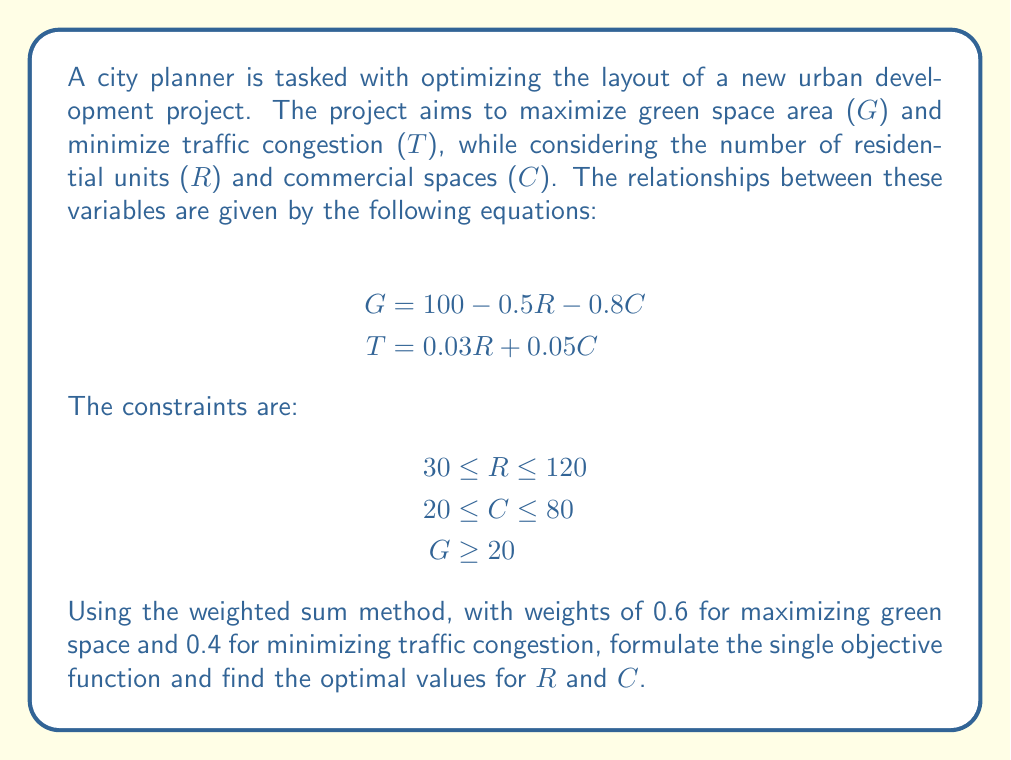Give your solution to this math problem. To solve this multi-objective optimization problem using the weighted sum method, we follow these steps:

1. Normalize the objectives:
   Both objectives need to be normalized to be on the same scale. We'll use the ideal and nadir points for normalization.

   For G (maximize): 
   Ideal = 100 (when R = C = 0)
   Nadir = 20 (minimum allowed)

   For T (minimize):
   Ideal = 0 (theoretical minimum)
   Nadir = 0.03 * 120 + 0.05 * 80 = 7.6 (maximum possible)

2. Formulate the normalized objectives:
   $$G_{norm} = \frac{G - 20}{100 - 20} = \frac{G - 20}{80}$$
   $$T_{norm} = \frac{7.6 - T}{7.6 - 0} = \frac{7.6 - T}{7.6}$$

3. Create the weighted sum objective function:
   $$Z = 0.6 \cdot G_{norm} + 0.4 \cdot T_{norm}$$

4. Substitute the original equations:
   $$Z = 0.6 \cdot \frac{(100 - 0.5R - 0.8C) - 20}{80} + 0.4 \cdot \frac{7.6 - (0.03R + 0.05C)}{7.6}$$

5. Simplify:
   $$Z = 0.6 \cdot \frac{80 - 0.5R - 0.8C}{80} + 0.4 \cdot \frac{7.6 - 0.03R - 0.05C}{7.6}$$
   $$Z = 0.0075(80 - 0.5R - 0.8C) + 0.0526(7.6 - 0.03R - 0.05C)$$
   $$Z = 0.6 + 0.4 - 0.00375R - 0.006C - 0.001578R - 0.00263C$$
   $$Z = 1 - 0.005328R - 0.00863C$$

6. The final single objective function to maximize is:
   $$Z = 1 - 0.005328R - 0.00863C$$

   Subject to constraints:
   $$30 \leq R \leq 120$$
   $$20 \leq C \leq 80$$
   $$100 - 0.5R - 0.8C \geq 20$$

7. This is a linear programming problem. We can solve it using the simplex method or by checking the corner points of the feasible region. The optimal solution will be at one of these corner points.

8. Solving this linear program (which can be done using software like LINGO or Excel Solver) gives the optimal solution.
Answer: The optimal solution is:
R = 120 (residential units)
C = 20 (commercial spaces)

This results in:
G = 44 (square units of green space)
T = 4.6 (traffic congestion measure)
Z = 0.5490 (optimal objective function value) 